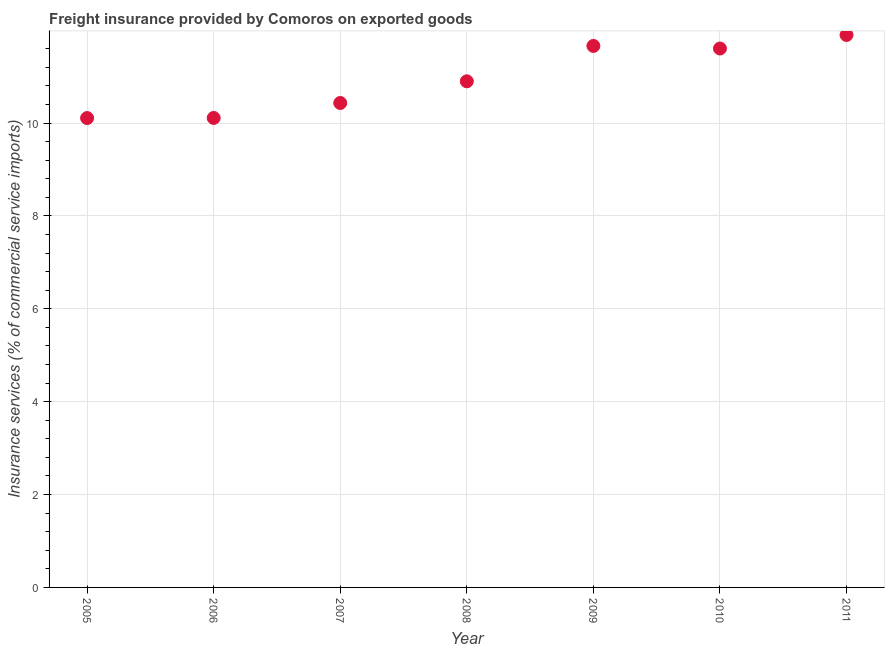What is the freight insurance in 2011?
Offer a very short reply. 11.9. Across all years, what is the maximum freight insurance?
Your answer should be compact. 11.9. Across all years, what is the minimum freight insurance?
Ensure brevity in your answer.  10.11. In which year was the freight insurance minimum?
Provide a short and direct response. 2005. What is the sum of the freight insurance?
Your response must be concise. 76.7. What is the difference between the freight insurance in 2005 and 2006?
Ensure brevity in your answer.  -0. What is the average freight insurance per year?
Your response must be concise. 10.96. What is the median freight insurance?
Offer a terse response. 10.9. In how many years, is the freight insurance greater than 5.2 %?
Your answer should be very brief. 7. What is the ratio of the freight insurance in 2008 to that in 2010?
Provide a succinct answer. 0.94. What is the difference between the highest and the second highest freight insurance?
Provide a short and direct response. 0.24. What is the difference between the highest and the lowest freight insurance?
Your answer should be very brief. 1.79. In how many years, is the freight insurance greater than the average freight insurance taken over all years?
Your response must be concise. 3. Does the freight insurance monotonically increase over the years?
Make the answer very short. No. How many dotlines are there?
Provide a short and direct response. 1. What is the difference between two consecutive major ticks on the Y-axis?
Offer a terse response. 2. Are the values on the major ticks of Y-axis written in scientific E-notation?
Your response must be concise. No. What is the title of the graph?
Ensure brevity in your answer.  Freight insurance provided by Comoros on exported goods . What is the label or title of the X-axis?
Provide a short and direct response. Year. What is the label or title of the Y-axis?
Your response must be concise. Insurance services (% of commercial service imports). What is the Insurance services (% of commercial service imports) in 2005?
Offer a very short reply. 10.11. What is the Insurance services (% of commercial service imports) in 2006?
Your answer should be very brief. 10.11. What is the Insurance services (% of commercial service imports) in 2007?
Provide a short and direct response. 10.43. What is the Insurance services (% of commercial service imports) in 2008?
Your response must be concise. 10.9. What is the Insurance services (% of commercial service imports) in 2009?
Keep it short and to the point. 11.66. What is the Insurance services (% of commercial service imports) in 2010?
Offer a very short reply. 11.6. What is the Insurance services (% of commercial service imports) in 2011?
Your answer should be compact. 11.9. What is the difference between the Insurance services (% of commercial service imports) in 2005 and 2006?
Ensure brevity in your answer.  -0. What is the difference between the Insurance services (% of commercial service imports) in 2005 and 2007?
Ensure brevity in your answer.  -0.32. What is the difference between the Insurance services (% of commercial service imports) in 2005 and 2008?
Offer a very short reply. -0.79. What is the difference between the Insurance services (% of commercial service imports) in 2005 and 2009?
Provide a short and direct response. -1.55. What is the difference between the Insurance services (% of commercial service imports) in 2005 and 2010?
Ensure brevity in your answer.  -1.5. What is the difference between the Insurance services (% of commercial service imports) in 2005 and 2011?
Offer a very short reply. -1.79. What is the difference between the Insurance services (% of commercial service imports) in 2006 and 2007?
Provide a short and direct response. -0.32. What is the difference between the Insurance services (% of commercial service imports) in 2006 and 2008?
Make the answer very short. -0.79. What is the difference between the Insurance services (% of commercial service imports) in 2006 and 2009?
Provide a short and direct response. -1.55. What is the difference between the Insurance services (% of commercial service imports) in 2006 and 2010?
Ensure brevity in your answer.  -1.5. What is the difference between the Insurance services (% of commercial service imports) in 2006 and 2011?
Provide a short and direct response. -1.79. What is the difference between the Insurance services (% of commercial service imports) in 2007 and 2008?
Keep it short and to the point. -0.47. What is the difference between the Insurance services (% of commercial service imports) in 2007 and 2009?
Keep it short and to the point. -1.23. What is the difference between the Insurance services (% of commercial service imports) in 2007 and 2010?
Your answer should be very brief. -1.17. What is the difference between the Insurance services (% of commercial service imports) in 2007 and 2011?
Ensure brevity in your answer.  -1.46. What is the difference between the Insurance services (% of commercial service imports) in 2008 and 2009?
Give a very brief answer. -0.76. What is the difference between the Insurance services (% of commercial service imports) in 2008 and 2010?
Offer a very short reply. -0.71. What is the difference between the Insurance services (% of commercial service imports) in 2008 and 2011?
Ensure brevity in your answer.  -1. What is the difference between the Insurance services (% of commercial service imports) in 2009 and 2010?
Make the answer very short. 0.06. What is the difference between the Insurance services (% of commercial service imports) in 2009 and 2011?
Make the answer very short. -0.24. What is the difference between the Insurance services (% of commercial service imports) in 2010 and 2011?
Offer a terse response. -0.29. What is the ratio of the Insurance services (% of commercial service imports) in 2005 to that in 2006?
Provide a short and direct response. 1. What is the ratio of the Insurance services (% of commercial service imports) in 2005 to that in 2008?
Provide a short and direct response. 0.93. What is the ratio of the Insurance services (% of commercial service imports) in 2005 to that in 2009?
Ensure brevity in your answer.  0.87. What is the ratio of the Insurance services (% of commercial service imports) in 2005 to that in 2010?
Your response must be concise. 0.87. What is the ratio of the Insurance services (% of commercial service imports) in 2006 to that in 2007?
Your response must be concise. 0.97. What is the ratio of the Insurance services (% of commercial service imports) in 2006 to that in 2008?
Keep it short and to the point. 0.93. What is the ratio of the Insurance services (% of commercial service imports) in 2006 to that in 2009?
Offer a terse response. 0.87. What is the ratio of the Insurance services (% of commercial service imports) in 2006 to that in 2010?
Provide a short and direct response. 0.87. What is the ratio of the Insurance services (% of commercial service imports) in 2006 to that in 2011?
Provide a succinct answer. 0.85. What is the ratio of the Insurance services (% of commercial service imports) in 2007 to that in 2008?
Keep it short and to the point. 0.96. What is the ratio of the Insurance services (% of commercial service imports) in 2007 to that in 2009?
Provide a succinct answer. 0.9. What is the ratio of the Insurance services (% of commercial service imports) in 2007 to that in 2010?
Offer a terse response. 0.9. What is the ratio of the Insurance services (% of commercial service imports) in 2007 to that in 2011?
Offer a very short reply. 0.88. What is the ratio of the Insurance services (% of commercial service imports) in 2008 to that in 2009?
Keep it short and to the point. 0.94. What is the ratio of the Insurance services (% of commercial service imports) in 2008 to that in 2010?
Ensure brevity in your answer.  0.94. What is the ratio of the Insurance services (% of commercial service imports) in 2008 to that in 2011?
Your answer should be compact. 0.92. What is the ratio of the Insurance services (% of commercial service imports) in 2009 to that in 2010?
Provide a short and direct response. 1. 